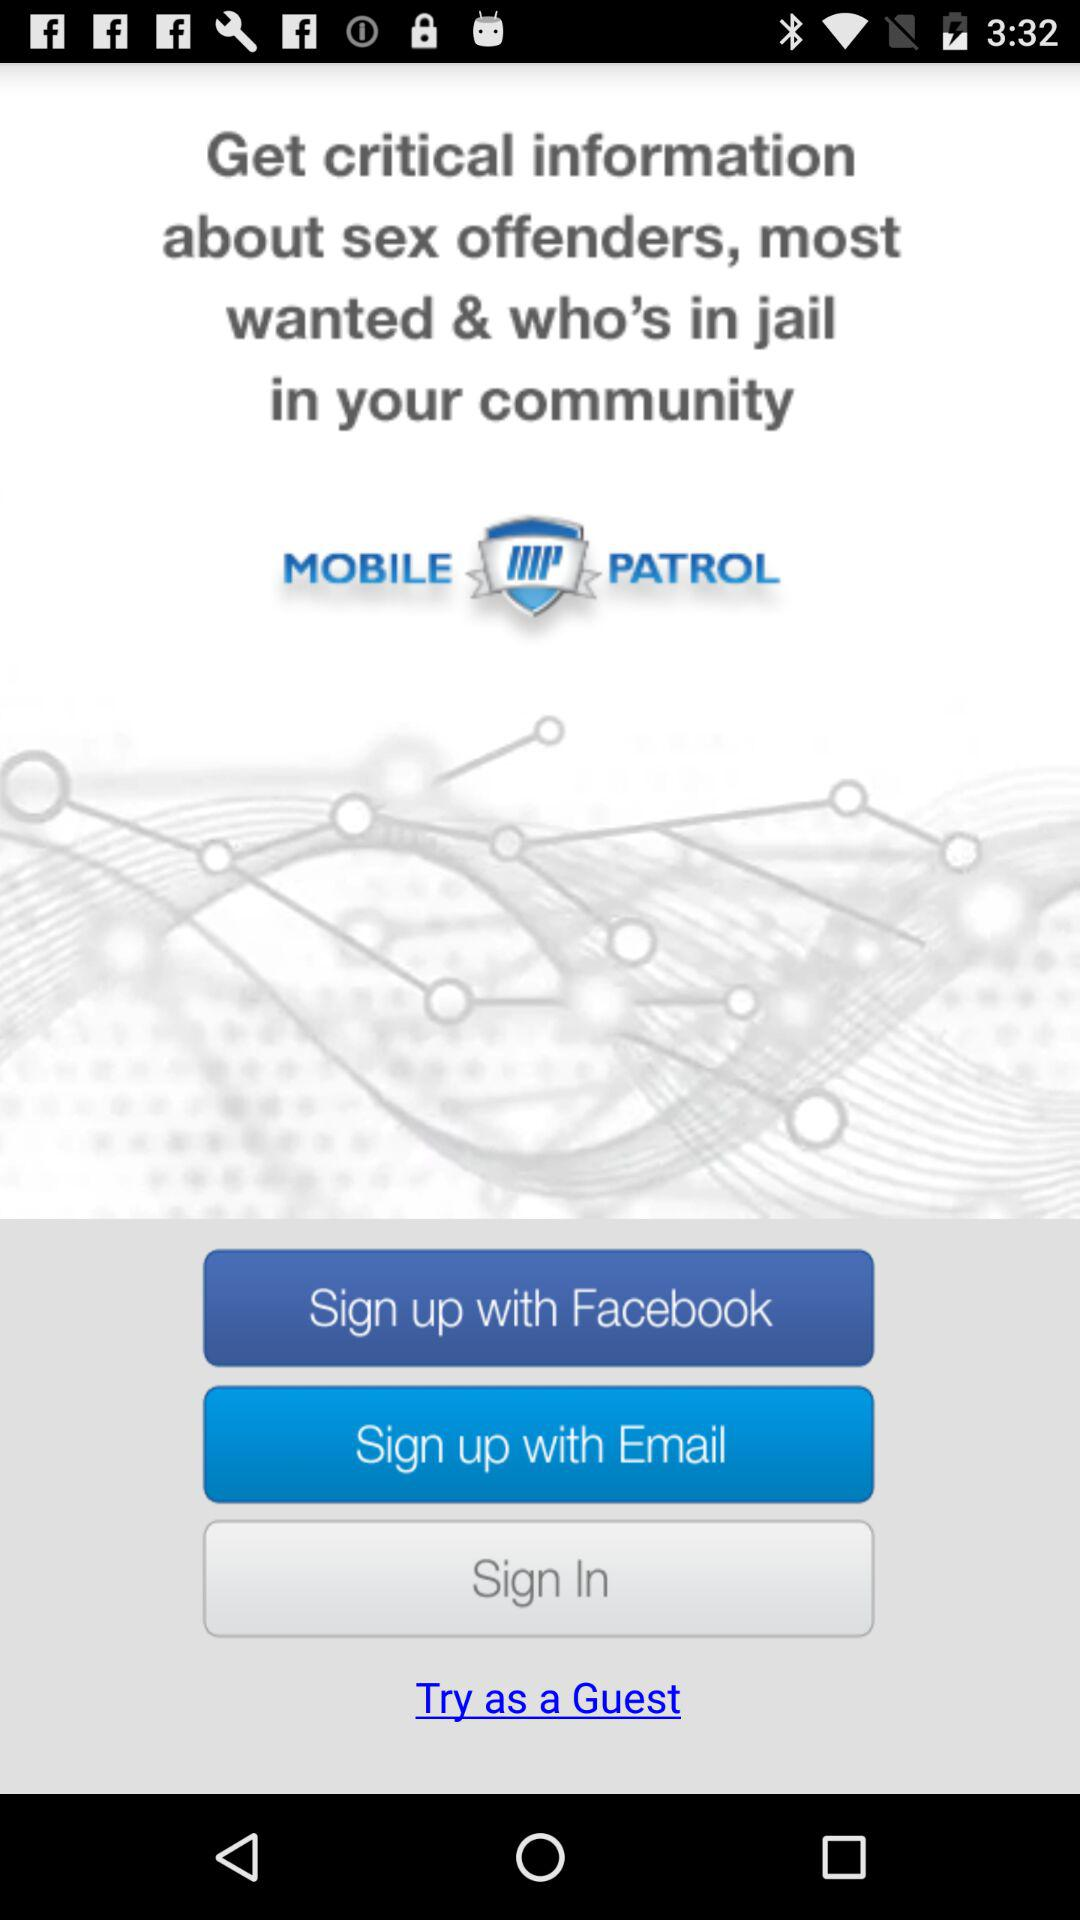Which account can be used to log in? The accounts that can be used to log in are "Facebook" and "Email". 